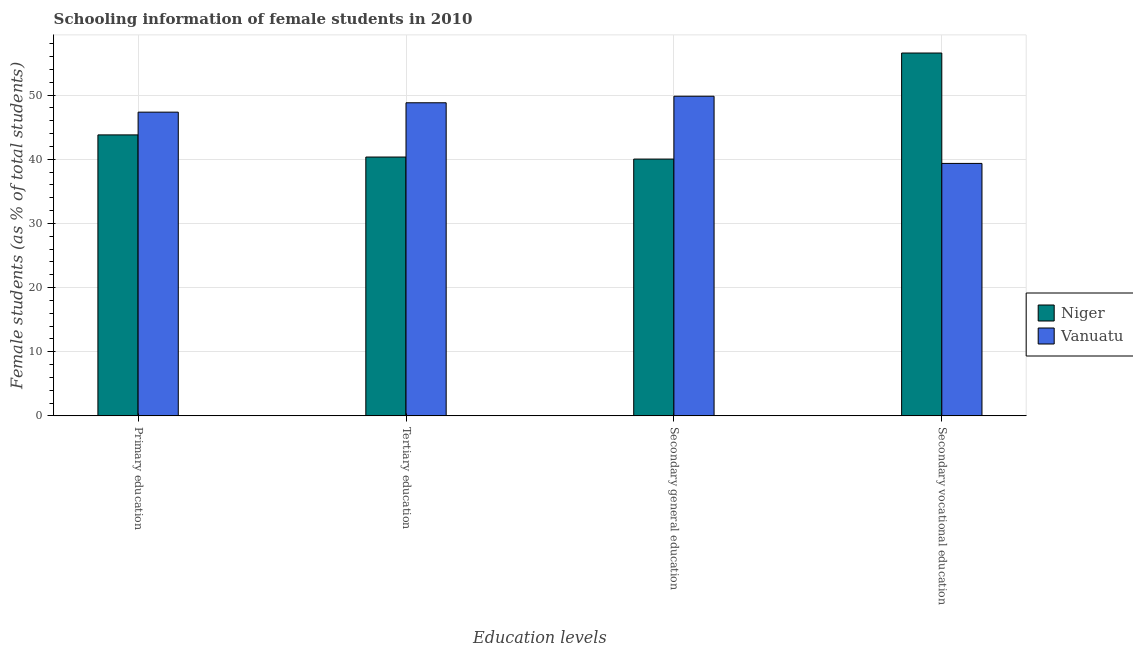How many bars are there on the 4th tick from the right?
Offer a terse response. 2. What is the percentage of female students in primary education in Vanuatu?
Ensure brevity in your answer.  47.34. Across all countries, what is the maximum percentage of female students in secondary education?
Keep it short and to the point. 49.83. Across all countries, what is the minimum percentage of female students in secondary education?
Your answer should be compact. 40.03. In which country was the percentage of female students in secondary vocational education maximum?
Ensure brevity in your answer.  Niger. In which country was the percentage of female students in tertiary education minimum?
Your answer should be compact. Niger. What is the total percentage of female students in secondary vocational education in the graph?
Your response must be concise. 95.91. What is the difference between the percentage of female students in secondary education in Niger and that in Vanuatu?
Your response must be concise. -9.8. What is the difference between the percentage of female students in primary education in Vanuatu and the percentage of female students in tertiary education in Niger?
Ensure brevity in your answer.  7. What is the average percentage of female students in secondary vocational education per country?
Your response must be concise. 47.96. What is the difference between the percentage of female students in secondary education and percentage of female students in tertiary education in Niger?
Your answer should be compact. -0.32. In how many countries, is the percentage of female students in secondary vocational education greater than 2 %?
Provide a short and direct response. 2. What is the ratio of the percentage of female students in secondary education in Vanuatu to that in Niger?
Make the answer very short. 1.24. Is the percentage of female students in primary education in Niger less than that in Vanuatu?
Your response must be concise. Yes. What is the difference between the highest and the second highest percentage of female students in secondary vocational education?
Offer a terse response. 17.21. What is the difference between the highest and the lowest percentage of female students in primary education?
Your answer should be very brief. 3.54. In how many countries, is the percentage of female students in tertiary education greater than the average percentage of female students in tertiary education taken over all countries?
Keep it short and to the point. 1. Is the sum of the percentage of female students in tertiary education in Niger and Vanuatu greater than the maximum percentage of female students in primary education across all countries?
Offer a terse response. Yes. Is it the case that in every country, the sum of the percentage of female students in tertiary education and percentage of female students in primary education is greater than the sum of percentage of female students in secondary education and percentage of female students in secondary vocational education?
Provide a succinct answer. No. What does the 2nd bar from the left in Tertiary education represents?
Keep it short and to the point. Vanuatu. What does the 2nd bar from the right in Secondary vocational education represents?
Your response must be concise. Niger. Are all the bars in the graph horizontal?
Offer a very short reply. No. How many countries are there in the graph?
Provide a succinct answer. 2. Where does the legend appear in the graph?
Make the answer very short. Center right. How are the legend labels stacked?
Offer a very short reply. Vertical. What is the title of the graph?
Provide a succinct answer. Schooling information of female students in 2010. Does "Northern Mariana Islands" appear as one of the legend labels in the graph?
Your answer should be very brief. No. What is the label or title of the X-axis?
Make the answer very short. Education levels. What is the label or title of the Y-axis?
Keep it short and to the point. Female students (as % of total students). What is the Female students (as % of total students) of Niger in Primary education?
Keep it short and to the point. 43.8. What is the Female students (as % of total students) of Vanuatu in Primary education?
Your response must be concise. 47.34. What is the Female students (as % of total students) of Niger in Tertiary education?
Make the answer very short. 40.35. What is the Female students (as % of total students) in Vanuatu in Tertiary education?
Your answer should be compact. 48.81. What is the Female students (as % of total students) of Niger in Secondary general education?
Your answer should be very brief. 40.03. What is the Female students (as % of total students) of Vanuatu in Secondary general education?
Give a very brief answer. 49.83. What is the Female students (as % of total students) of Niger in Secondary vocational education?
Ensure brevity in your answer.  56.56. What is the Female students (as % of total students) of Vanuatu in Secondary vocational education?
Provide a succinct answer. 39.35. Across all Education levels, what is the maximum Female students (as % of total students) of Niger?
Your answer should be compact. 56.56. Across all Education levels, what is the maximum Female students (as % of total students) of Vanuatu?
Give a very brief answer. 49.83. Across all Education levels, what is the minimum Female students (as % of total students) of Niger?
Provide a succinct answer. 40.03. Across all Education levels, what is the minimum Female students (as % of total students) of Vanuatu?
Your answer should be very brief. 39.35. What is the total Female students (as % of total students) in Niger in the graph?
Your response must be concise. 180.74. What is the total Female students (as % of total students) of Vanuatu in the graph?
Provide a succinct answer. 185.33. What is the difference between the Female students (as % of total students) of Niger in Primary education and that in Tertiary education?
Provide a short and direct response. 3.45. What is the difference between the Female students (as % of total students) in Vanuatu in Primary education and that in Tertiary education?
Offer a very short reply. -1.46. What is the difference between the Female students (as % of total students) of Niger in Primary education and that in Secondary general education?
Provide a short and direct response. 3.77. What is the difference between the Female students (as % of total students) in Vanuatu in Primary education and that in Secondary general education?
Provide a succinct answer. -2.48. What is the difference between the Female students (as % of total students) of Niger in Primary education and that in Secondary vocational education?
Provide a short and direct response. -12.76. What is the difference between the Female students (as % of total students) of Vanuatu in Primary education and that in Secondary vocational education?
Give a very brief answer. 7.99. What is the difference between the Female students (as % of total students) of Niger in Tertiary education and that in Secondary general education?
Give a very brief answer. 0.32. What is the difference between the Female students (as % of total students) in Vanuatu in Tertiary education and that in Secondary general education?
Your answer should be very brief. -1.02. What is the difference between the Female students (as % of total students) in Niger in Tertiary education and that in Secondary vocational education?
Keep it short and to the point. -16.21. What is the difference between the Female students (as % of total students) in Vanuatu in Tertiary education and that in Secondary vocational education?
Provide a short and direct response. 9.45. What is the difference between the Female students (as % of total students) in Niger in Secondary general education and that in Secondary vocational education?
Your answer should be very brief. -16.53. What is the difference between the Female students (as % of total students) in Vanuatu in Secondary general education and that in Secondary vocational education?
Your answer should be very brief. 10.48. What is the difference between the Female students (as % of total students) in Niger in Primary education and the Female students (as % of total students) in Vanuatu in Tertiary education?
Make the answer very short. -5.01. What is the difference between the Female students (as % of total students) in Niger in Primary education and the Female students (as % of total students) in Vanuatu in Secondary general education?
Ensure brevity in your answer.  -6.03. What is the difference between the Female students (as % of total students) of Niger in Primary education and the Female students (as % of total students) of Vanuatu in Secondary vocational education?
Provide a short and direct response. 4.45. What is the difference between the Female students (as % of total students) of Niger in Tertiary education and the Female students (as % of total students) of Vanuatu in Secondary general education?
Make the answer very short. -9.48. What is the difference between the Female students (as % of total students) in Niger in Tertiary education and the Female students (as % of total students) in Vanuatu in Secondary vocational education?
Offer a very short reply. 0.99. What is the difference between the Female students (as % of total students) in Niger in Secondary general education and the Female students (as % of total students) in Vanuatu in Secondary vocational education?
Provide a succinct answer. 0.68. What is the average Female students (as % of total students) of Niger per Education levels?
Provide a short and direct response. 45.19. What is the average Female students (as % of total students) in Vanuatu per Education levels?
Make the answer very short. 46.33. What is the difference between the Female students (as % of total students) in Niger and Female students (as % of total students) in Vanuatu in Primary education?
Ensure brevity in your answer.  -3.54. What is the difference between the Female students (as % of total students) in Niger and Female students (as % of total students) in Vanuatu in Tertiary education?
Offer a very short reply. -8.46. What is the difference between the Female students (as % of total students) in Niger and Female students (as % of total students) in Vanuatu in Secondary general education?
Provide a succinct answer. -9.8. What is the difference between the Female students (as % of total students) of Niger and Female students (as % of total students) of Vanuatu in Secondary vocational education?
Give a very brief answer. 17.21. What is the ratio of the Female students (as % of total students) in Niger in Primary education to that in Tertiary education?
Offer a terse response. 1.09. What is the ratio of the Female students (as % of total students) in Vanuatu in Primary education to that in Tertiary education?
Your response must be concise. 0.97. What is the ratio of the Female students (as % of total students) of Niger in Primary education to that in Secondary general education?
Provide a succinct answer. 1.09. What is the ratio of the Female students (as % of total students) in Vanuatu in Primary education to that in Secondary general education?
Offer a very short reply. 0.95. What is the ratio of the Female students (as % of total students) in Niger in Primary education to that in Secondary vocational education?
Offer a terse response. 0.77. What is the ratio of the Female students (as % of total students) of Vanuatu in Primary education to that in Secondary vocational education?
Your answer should be very brief. 1.2. What is the ratio of the Female students (as % of total students) in Niger in Tertiary education to that in Secondary general education?
Your response must be concise. 1.01. What is the ratio of the Female students (as % of total students) of Vanuatu in Tertiary education to that in Secondary general education?
Your answer should be very brief. 0.98. What is the ratio of the Female students (as % of total students) in Niger in Tertiary education to that in Secondary vocational education?
Provide a short and direct response. 0.71. What is the ratio of the Female students (as % of total students) of Vanuatu in Tertiary education to that in Secondary vocational education?
Offer a very short reply. 1.24. What is the ratio of the Female students (as % of total students) in Niger in Secondary general education to that in Secondary vocational education?
Ensure brevity in your answer.  0.71. What is the ratio of the Female students (as % of total students) of Vanuatu in Secondary general education to that in Secondary vocational education?
Give a very brief answer. 1.27. What is the difference between the highest and the second highest Female students (as % of total students) in Niger?
Give a very brief answer. 12.76. What is the difference between the highest and the second highest Female students (as % of total students) in Vanuatu?
Keep it short and to the point. 1.02. What is the difference between the highest and the lowest Female students (as % of total students) in Niger?
Your answer should be compact. 16.53. What is the difference between the highest and the lowest Female students (as % of total students) of Vanuatu?
Offer a very short reply. 10.48. 